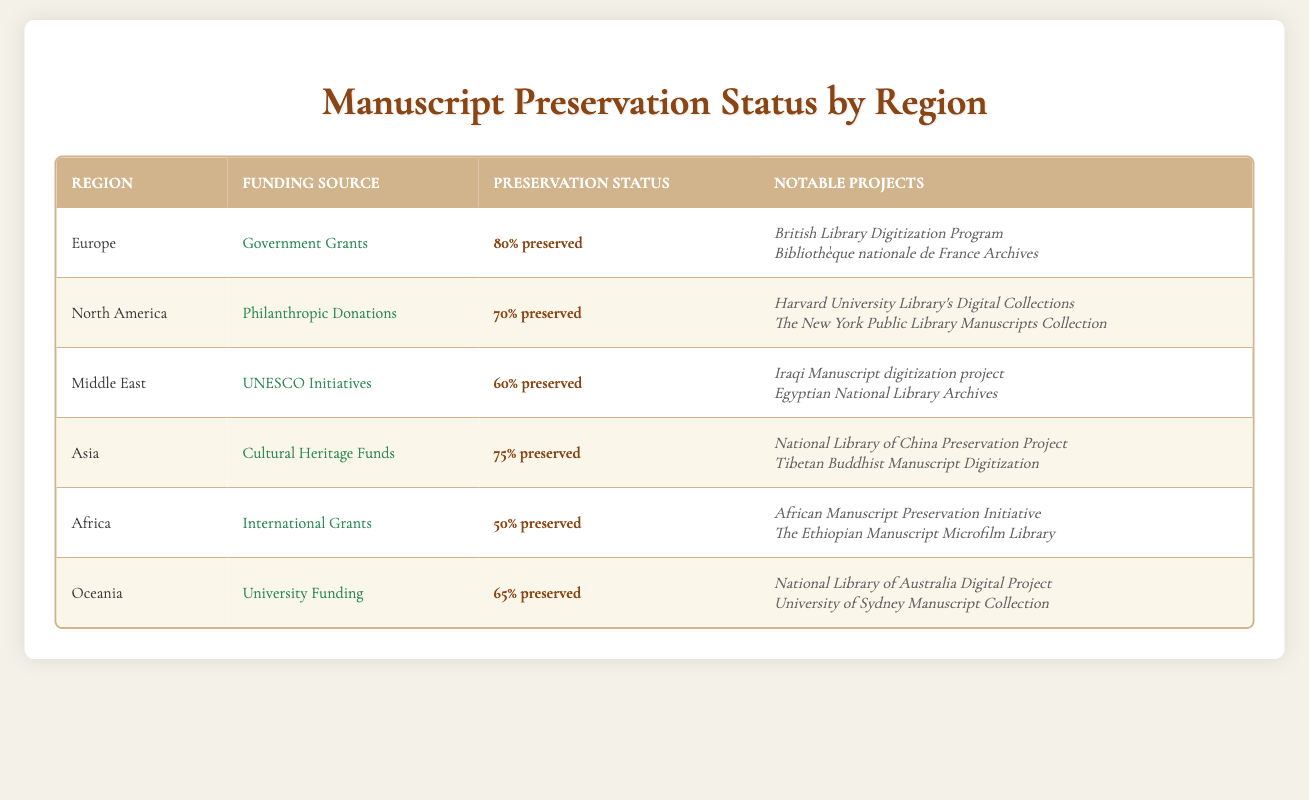What is the preservation status of manuscripts in Europe? The table clearly shows that Europe has a preservation status of 80% preserved. This information is found in the row corresponding to the region Europe.
Answer: 80% preserved Which region has the lowest preservation status? By examining the Preservation Status column, Africa is listed with a preservation status of 50% preserved, which is the lowest compared to the other regions.
Answer: Africa What notable projects are funded by governmental grants in Europe? The notable projects for Europe under the Government Grants funding source are listed as the British Library Digitization Program and the Bibliothèque nationale de France Archives. This can be found in the same row as Europe in the table.
Answer: British Library Digitization Program, Bibliothèque nationale de France Archives What is the average preservation status across all regions? The preservation statuses are: 80%, 70%, 60%, 75%, 50%, and 65%. First, convert them into numerical values: 80, 70, 60, 75, 50, 65. The sum is 400 (80 + 70 + 60 + 75 + 50 + 65 = 400). There are 6 regions, so the average is 400 / 6, which equals approximately 66.67%.
Answer: 66.67% Is the preservation status in Asia higher than in the Middle East? The table shows that Asia's preservation status is 75% preserved while the Middle East's is 60% preserved. Since 75% is greater than 60%, the answer is yes.
Answer: Yes How many regions have a preservation status above 65%? Looking at the table, Europe (80%), North America (70%), and Asia (75%) have preservation statuses above 65%. We count the regions satisfying this criterion, which totals three regions.
Answer: 3 Are there any notable projects mentioned for the Middle East? Yes, the notable projects listed for the Middle East include the Iraqi Manuscript digitization project and the Egyptian National Library Archives, as seen in that region's row.
Answer: Yes Which funding source is used for preservation in Africa? According to the table, the funding source for preservation in Africa is International Grants. This information is found in the row corresponding to the Africa region.
Answer: International Grants 